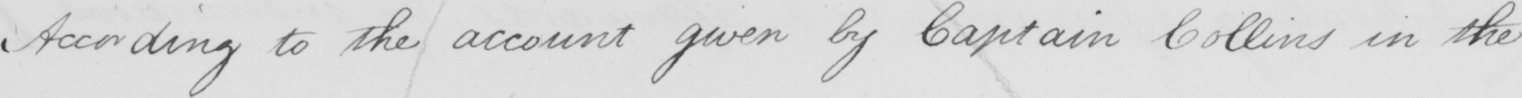What does this handwritten line say? According to the account given by Captain Collins in the 